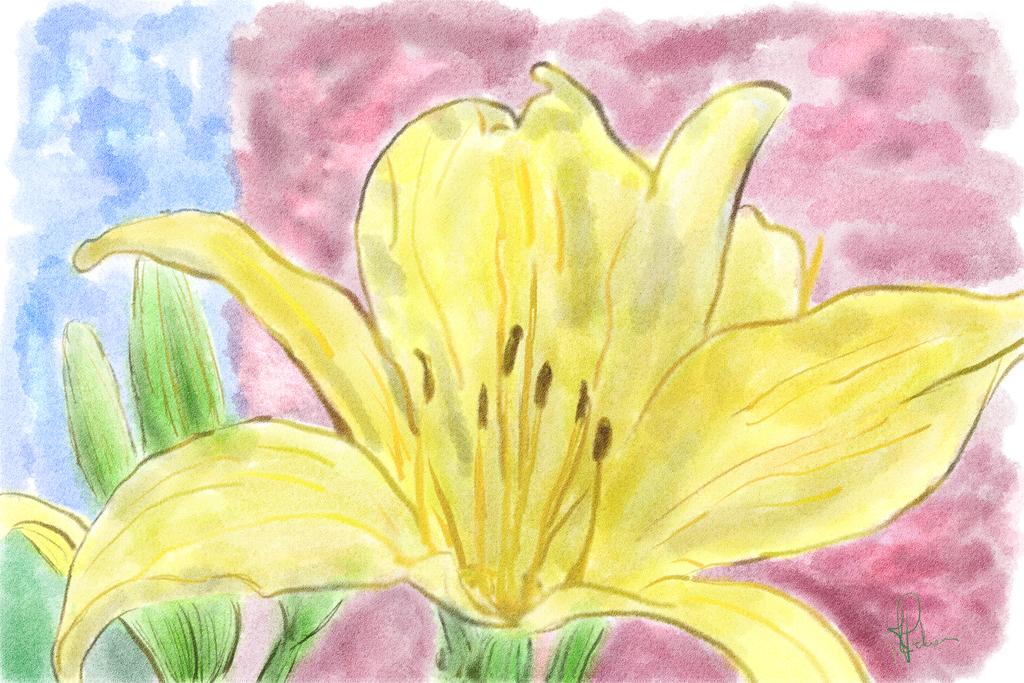What is the main subject of the image? There is a flower in the image. Can you describe the flower in the image? Unfortunately, the provided facts do not include any details about the flower's appearance or characteristics. Is there anything else in the image besides the flower? The provided facts do not mention any other objects or subjects in the image. How many heads are visible in the image? There are no heads visible in the image, as it only features a flower. What type of connection can be seen between the flower and the ground in the image? There is no connection between the flower and the ground visible in the image, as it only features a flower. 